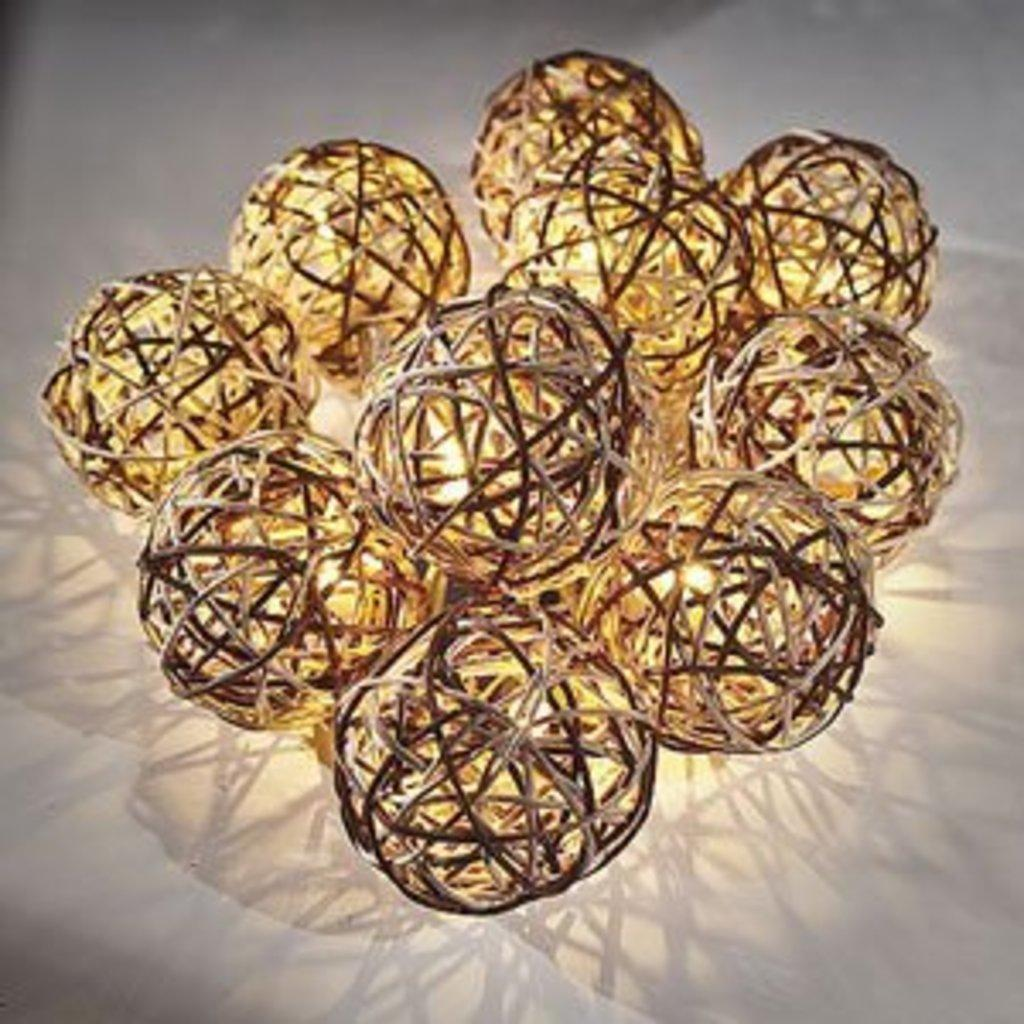What objects are present in the image? There are decorative balls in the image. What color is the background of the image? The background of the image is white. How many people are wearing a skirt in the image? There are no people present in the image, so it is not possible to determine if anyone is wearing a skirt. 